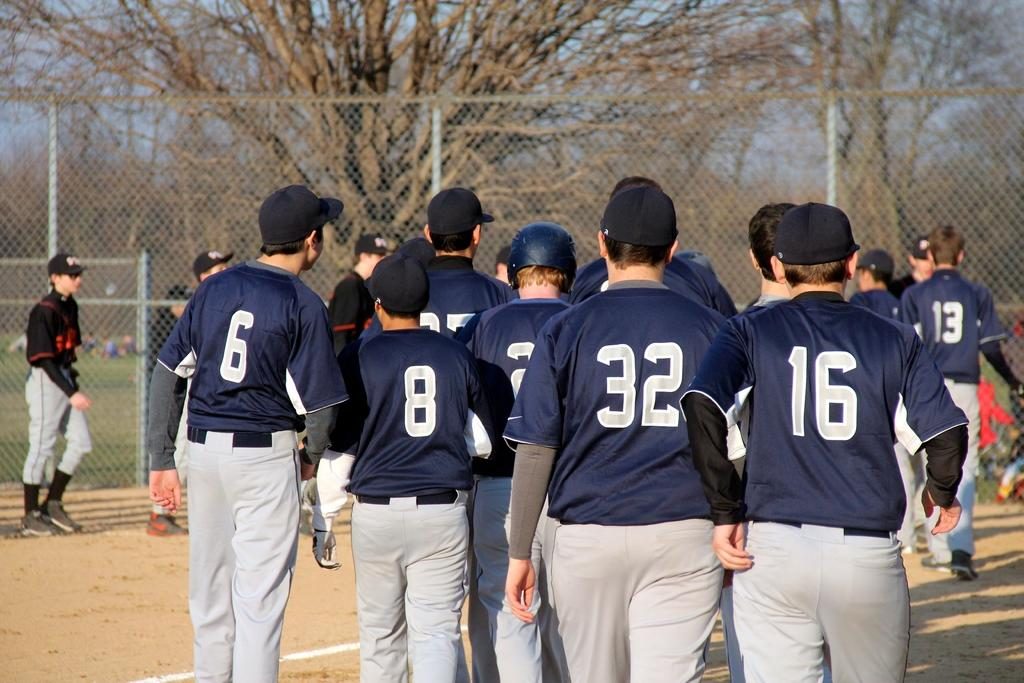Provide a one-sentence caption for the provided image. a group of players standing and one wears 16. 